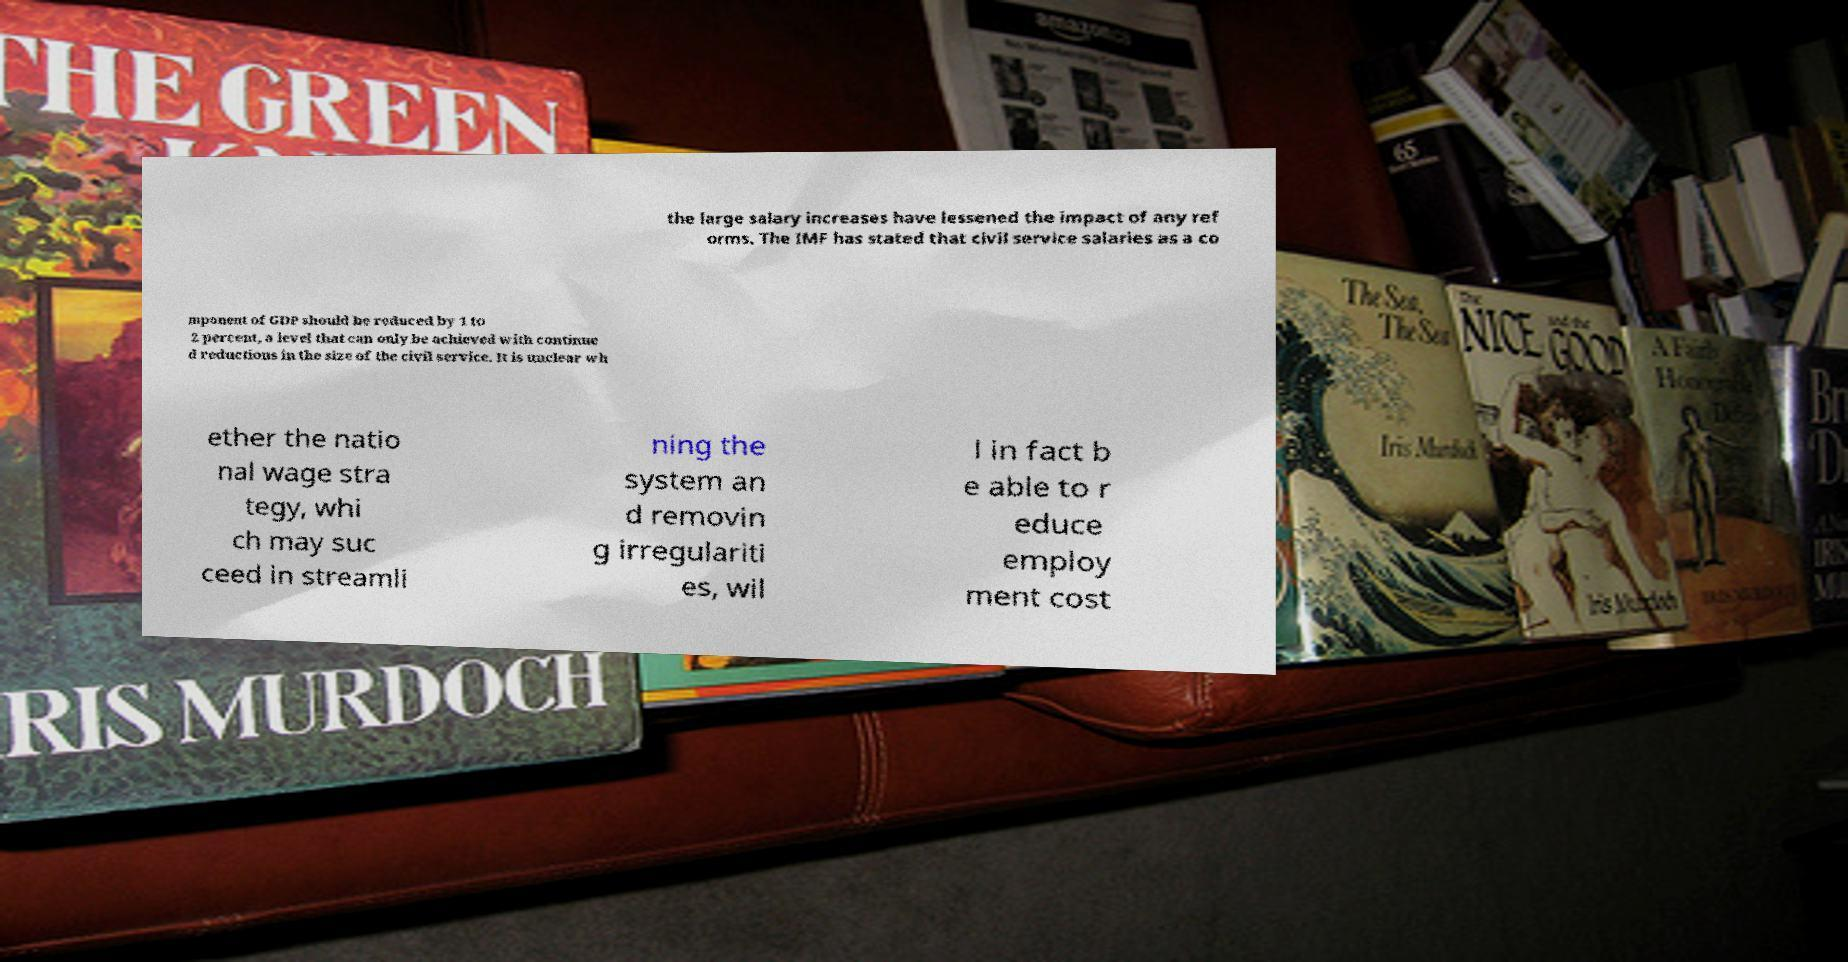Could you extract and type out the text from this image? the large salary increases have lessened the impact of any ref orms. The IMF has stated that civil service salaries as a co mponent of GDP should be reduced by 1 to 2 percent, a level that can only be achieved with continue d reductions in the size of the civil service. It is unclear wh ether the natio nal wage stra tegy, whi ch may suc ceed in streamli ning the system an d removin g irregulariti es, wil l in fact b e able to r educe employ ment cost 